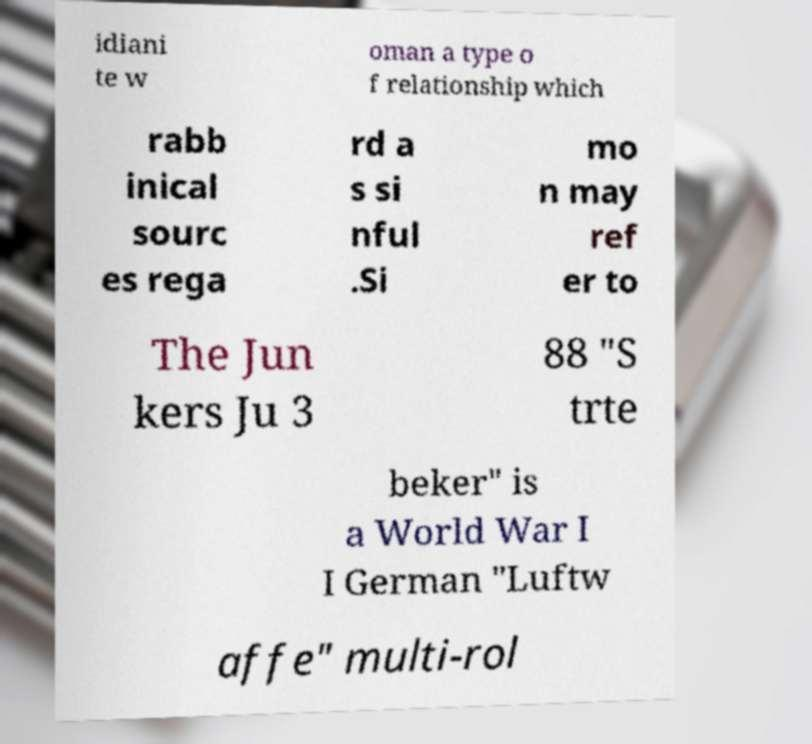Can you read and provide the text displayed in the image?This photo seems to have some interesting text. Can you extract and type it out for me? idiani te w oman a type o f relationship which rabb inical sourc es rega rd a s si nful .Si mo n may ref er to The Jun kers Ju 3 88 "S trte beker" is a World War I I German "Luftw affe" multi-rol 